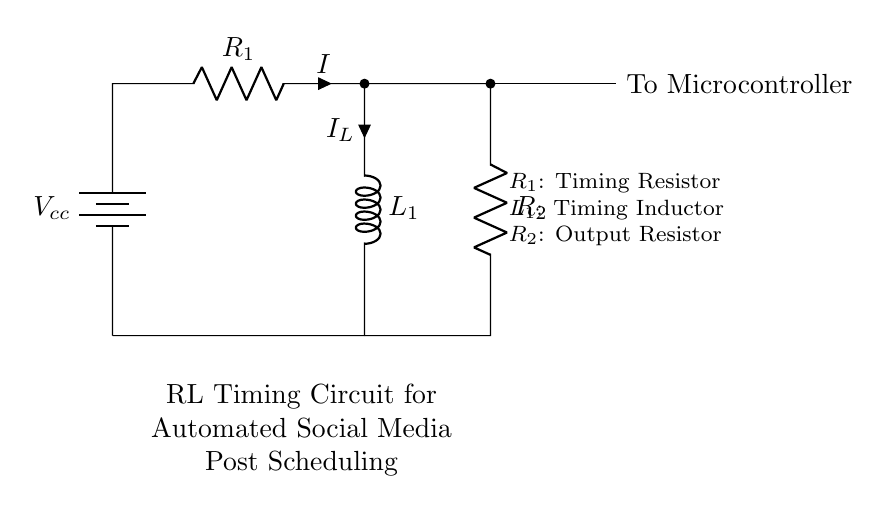What is the component labeled R1? R1 is a timing resistor, which is used in the RL timing circuit to determine the time constant of the circuit along with the inductor.
Answer: Timing Resistor What connects the inductor L1 to the circuit? The inductor L1 is connected in series with the timing resistor R1. The other end of L1 connects back to the battery, creating a closed loop.
Answer: Timing Resistor and Battery What is the purpose of R2 in this circuit? R2 is an output resistor, which likely serves to limit the current flowing to the connected microcontroller to prevent damage.
Answer: Output Resistor What does the abbreviation Vcc represent? Vcc represents the voltage supply for the circuit, indicating the positive terminal of the battery or power source.
Answer: Voltage Supply How does the time constant of this RL circuit affect posting frequency? The time constant (calculated as L1 divided by R1) determines how quickly the circuit responds to changes. A larger time constant will slow down the response, potentially delaying scheduled posts.
Answer: Time Constant What is the relationship between voltage and current in an RL circuit during switching? In an RL circuit, during the switch-on phase, the inductor initially opposes changes in current flow, leading to a gradual increase in current rather than an immediate surge, which can affect the timing of signals sent to the microcontroller.
Answer: Gradual Increase 